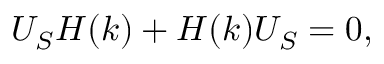<formula> <loc_0><loc_0><loc_500><loc_500>{ U _ { S } H ( k ) + H ( k ) U _ { S } = 0 , }</formula> 